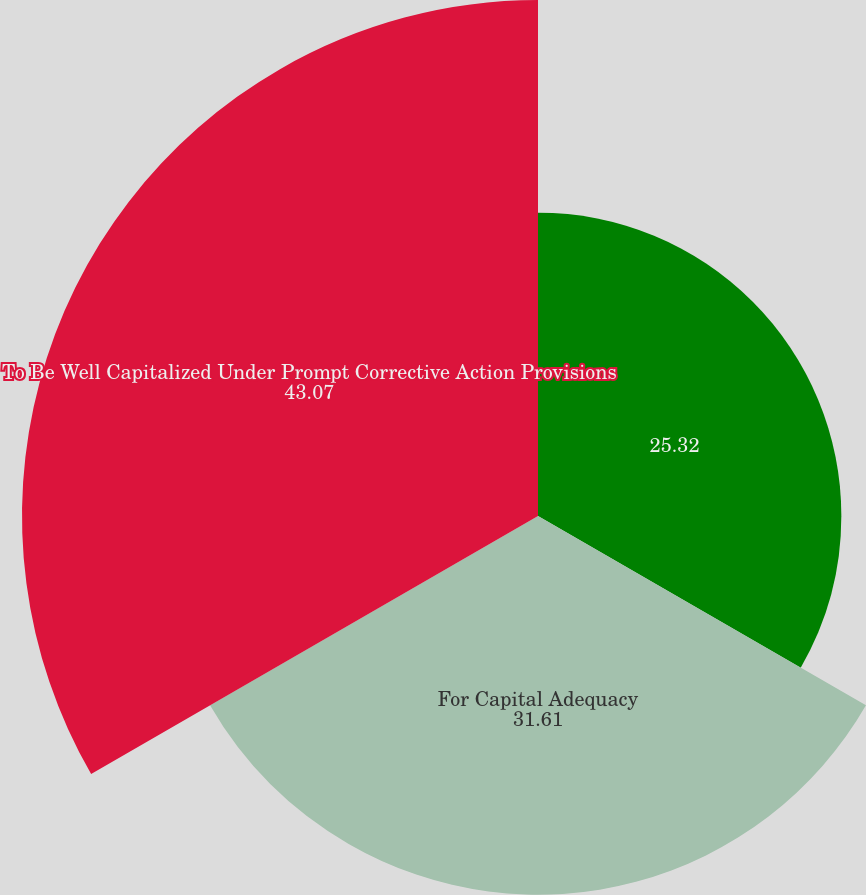Convert chart. <chart><loc_0><loc_0><loc_500><loc_500><pie_chart><ecel><fcel>For Capital Adequacy<fcel>To Be Well Capitalized Under Prompt Corrective Action Provisions<nl><fcel>25.32%<fcel>31.61%<fcel>43.07%<nl></chart> 